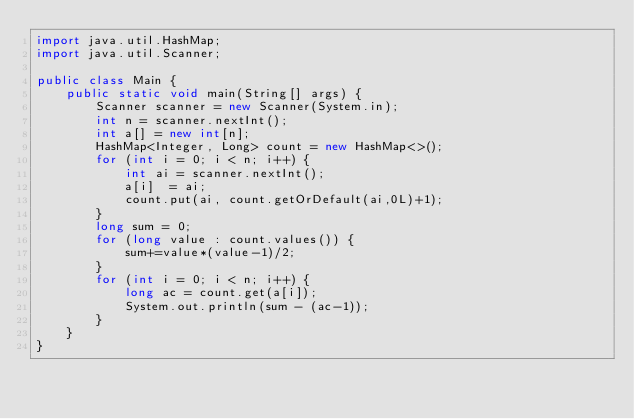<code> <loc_0><loc_0><loc_500><loc_500><_Java_>import java.util.HashMap;
import java.util.Scanner;

public class Main {
    public static void main(String[] args) {
        Scanner scanner = new Scanner(System.in);
        int n = scanner.nextInt();
        int a[] = new int[n];
        HashMap<Integer, Long> count = new HashMap<>();
        for (int i = 0; i < n; i++) {
            int ai = scanner.nextInt();
            a[i]  = ai;
            count.put(ai, count.getOrDefault(ai,0L)+1);
        }
        long sum = 0;
        for (long value : count.values()) {
            sum+=value*(value-1)/2;
        }
        for (int i = 0; i < n; i++) {
            long ac = count.get(a[i]);
            System.out.println(sum - (ac-1));
        }
    }
}</code> 